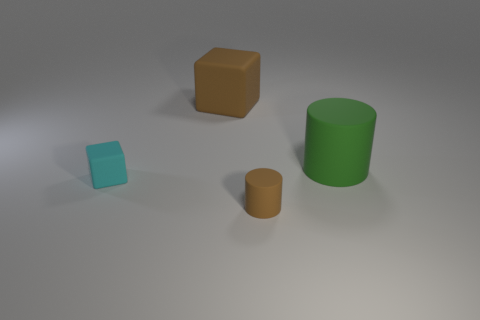Add 4 large green cylinders. How many objects exist? 8 Subtract 0 gray cylinders. How many objects are left? 4 Subtract all blue blocks. Subtract all purple cylinders. How many blocks are left? 2 Subtract all purple matte spheres. Subtract all rubber objects. How many objects are left? 0 Add 3 big matte cylinders. How many big matte cylinders are left? 4 Add 1 brown blocks. How many brown blocks exist? 2 